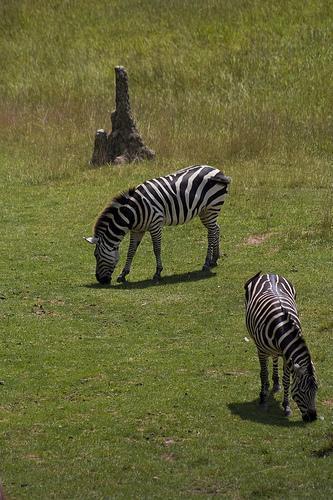How many zebras are there?
Give a very brief answer. 2. 